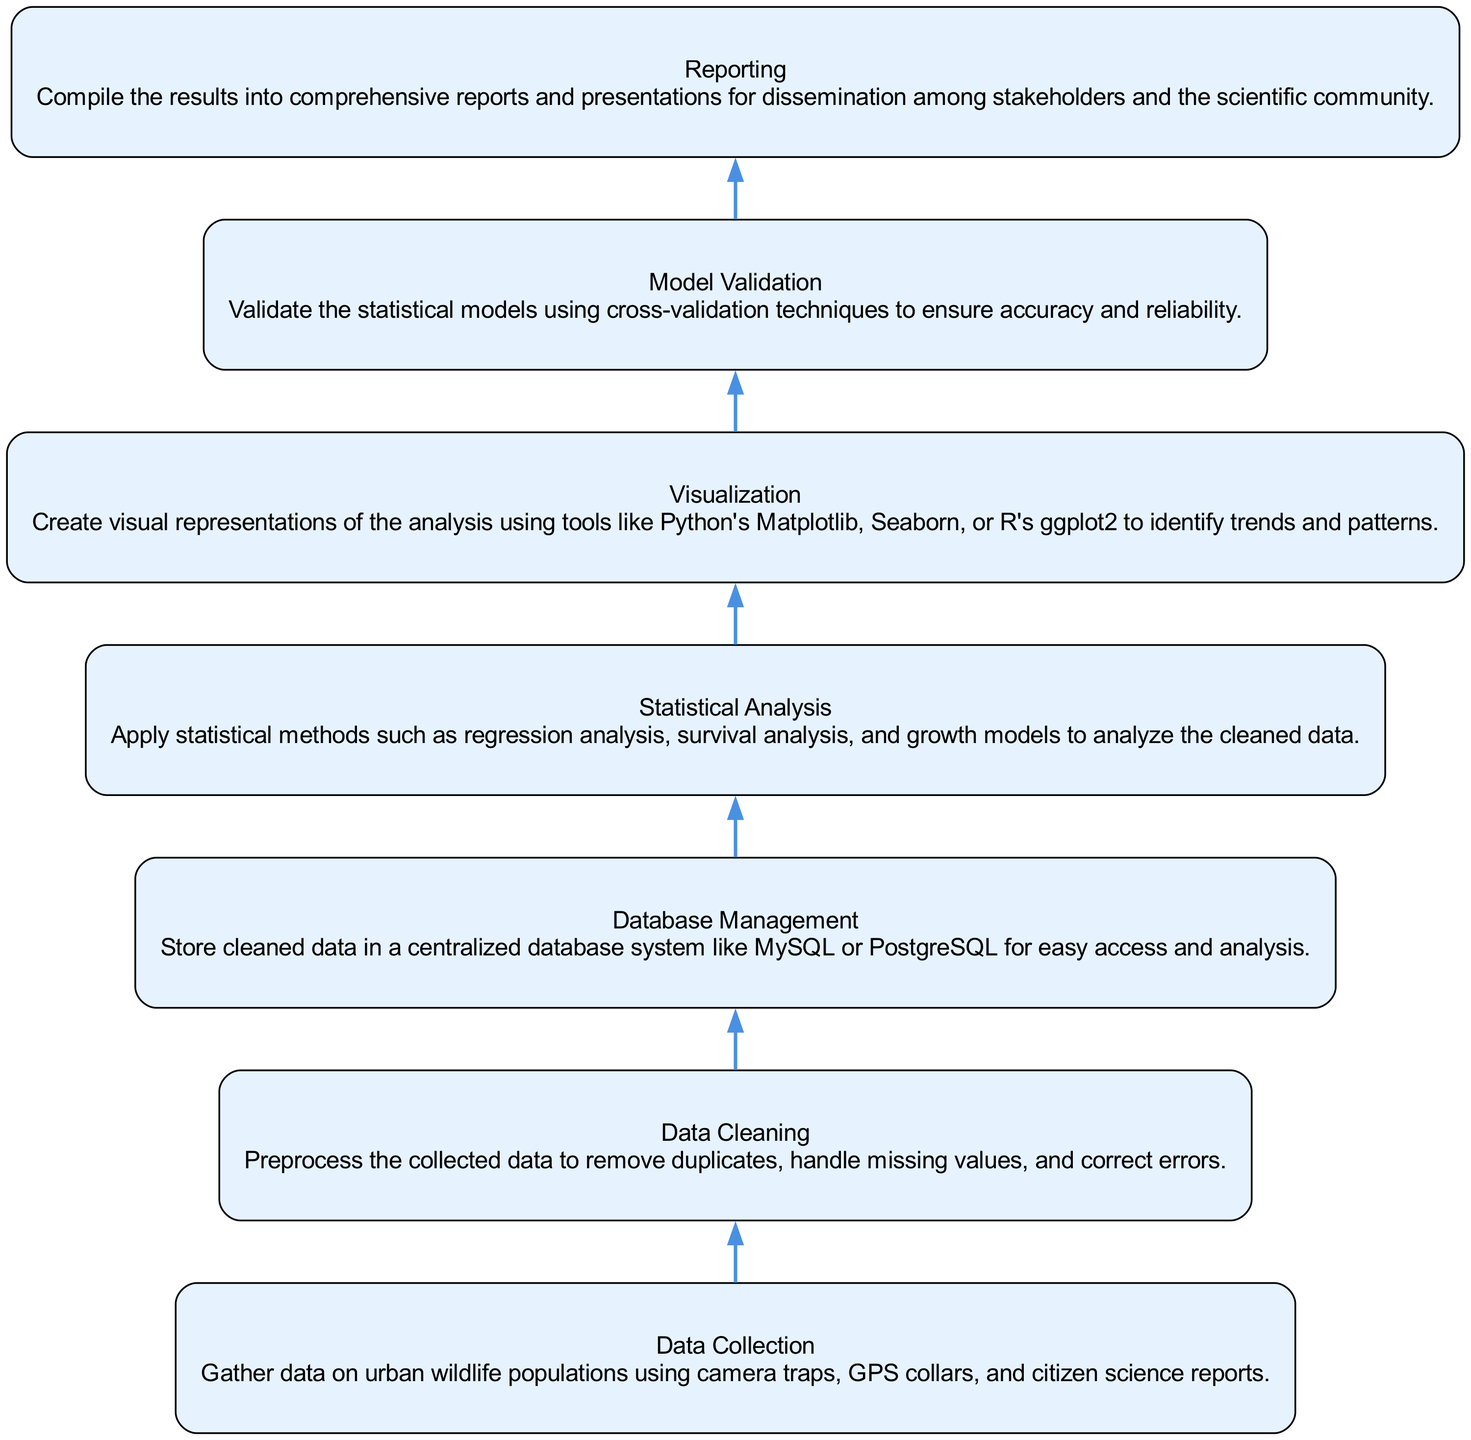What is the first step in the methodology? The diagram presents "Data Collection" as the first step in the flow from the bottom to the top.
Answer: Data Collection How many steps are shown in the methodology? By counting all the nodes in the diagram, there are a total of seven steps represented.
Answer: Seven Which step follows "Data Cleaning"? Referring to the flow chart, "Database Management" directly follows "Data Cleaning" in the methodology.
Answer: Database Management What is the main purpose of "Model Validation"? The diagram states that "Model Validation" is aimed at ensuring accuracy and reliability of the statistical models used.
Answer: Ensure accuracy and reliability What type of statistical methods are used in the "Statistical Analysis" step? The description in the node mentions "regression analysis, survival analysis, and growth models" as the statistical methods applied during this step.
Answer: Regression analysis, survival analysis, and growth models What is the last step in the methodology for tracking population growth? The diagram shows that "Reporting" is the final step in the process of tracking urban wildlife populations.
Answer: Reporting Which step involves creating visual representations? The node labeled "Visualization" in the flow chart specifically identifies the creation of visual representations as part of its description.
Answer: Visualization What is the relationship between "Database Management" and "Statistical Analysis"? The flow from the diagram illustrates that "Database Management" leads to "Statistical Analysis", indicating that the cleaned data from the database is used for analysis.
Answer: Database Management leads to Statistical Analysis What tools are mentioned for visualization? The node explains that tools like Python's Matplotlib, Seaborn, or R's ggplot2 are used for visualization in the methodology.
Answer: Python's Matplotlib, Seaborn, or R's ggplot2 